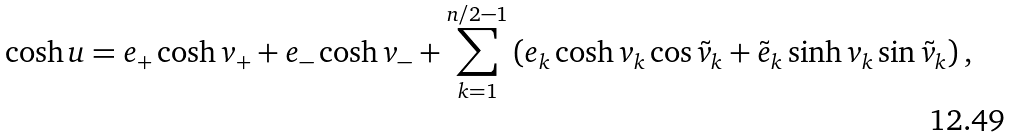Convert formula to latex. <formula><loc_0><loc_0><loc_500><loc_500>\cosh u = e _ { + } \cosh v _ { + } + e _ { - } \cosh v _ { - } + \sum _ { k = 1 } ^ { n / 2 - 1 } \left ( e _ { k } \cosh v _ { k } \cos \tilde { v } _ { k } + \tilde { e } _ { k } \sinh v _ { k } \sin \tilde { v } _ { k } \right ) ,</formula> 